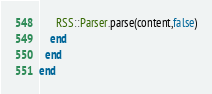<code> <loc_0><loc_0><loc_500><loc_500><_Ruby_>      RSS::Parser.parse(content,false)
    end
  end
end
</code> 